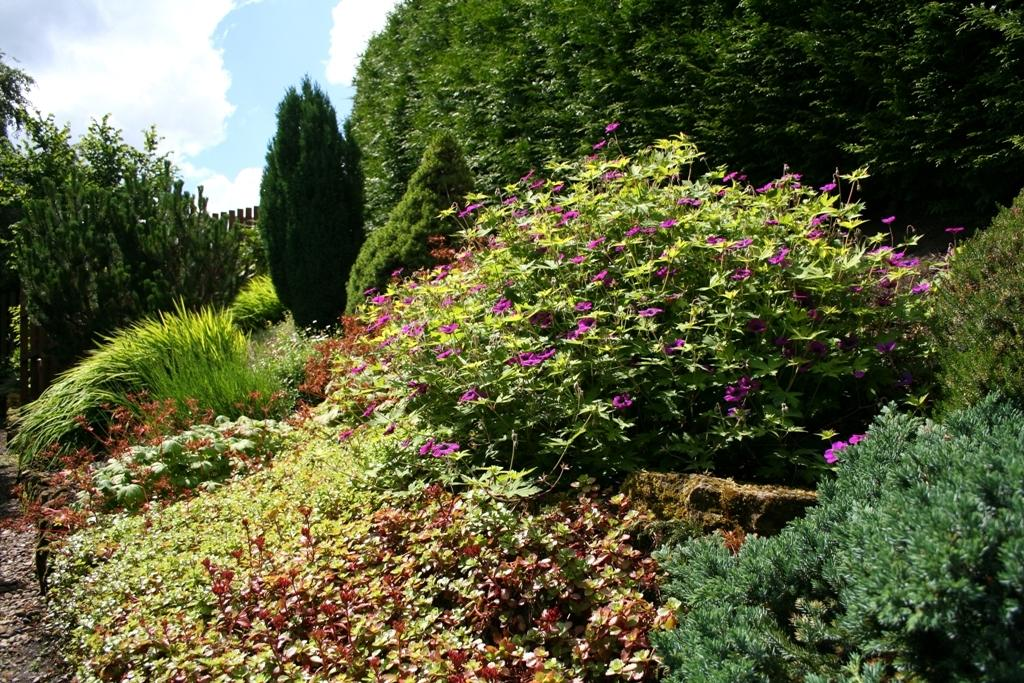What type of vegetation can be seen in the image? There are plants and trees in the image. What part of the natural environment is visible in the image? The sky is visible in the background of the image. Can you describe the setting where the plants and trees are located? The image suggests a natural outdoor setting, given the presence of plants, trees, and the sky. What type of legal advice is the lawyer providing to the army in the image? There is no army or lawyer present in the image; it features plants, trees, and the sky. 